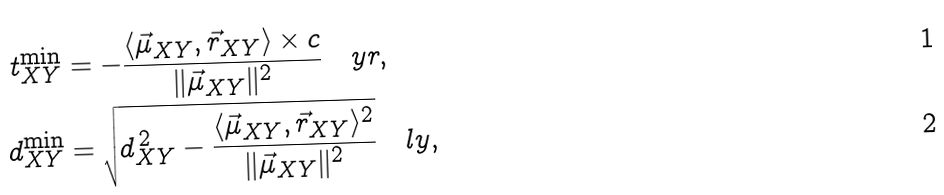<formula> <loc_0><loc_0><loc_500><loc_500>t _ { X Y } ^ { \min } & = - \frac { \langle \vec { \mu } _ { X Y } , \vec { r } _ { X Y } \rangle \times c } { \| \vec { \mu } _ { X Y } \| ^ { 2 } } \quad y r , \\ d _ { X Y } ^ { \min } & = \sqrt { d _ { X Y } ^ { \, 2 } - \frac { \langle \vec { \mu } _ { X Y } , \vec { r } _ { X Y } \rangle ^ { 2 } } { \| \vec { \mu } _ { X Y } \| ^ { 2 } } } \quad l y ,</formula> 